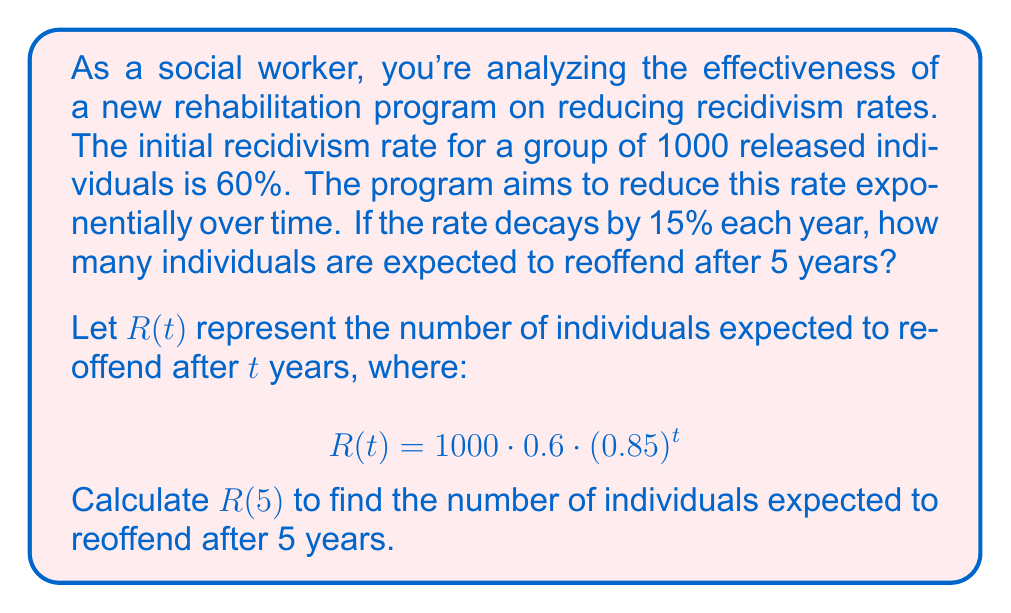Show me your answer to this math problem. Let's break this down step-by-step:

1) We start with the given exponential decay function:
   $$R(t) = 1000 \cdot 0.6 \cdot (0.85)^t$$

2) We need to calculate $R(5)$, so we substitute $t = 5$:
   $$R(5) = 1000 \cdot 0.6 \cdot (0.85)^5$$

3) Let's calculate this in parts:
   a) First, calculate $(0.85)^5$:
      $(0.85)^5 \approx 0.4437$ (rounded to 4 decimal places)

   b) Now, multiply all the parts:
      $1000 \cdot 0.6 \cdot 0.4437 \approx 266.22$

4) Since we're dealing with people, we need to round down to the nearest whole number.

Therefore, after 5 years, approximately 266 individuals are expected to reoffend.

This exponential decay model shows how the rehabilitation program could potentially reduce recidivism over time, which is crucial information for social workers advocating for more effective rehabilitation programs.
Answer: 266 individuals 